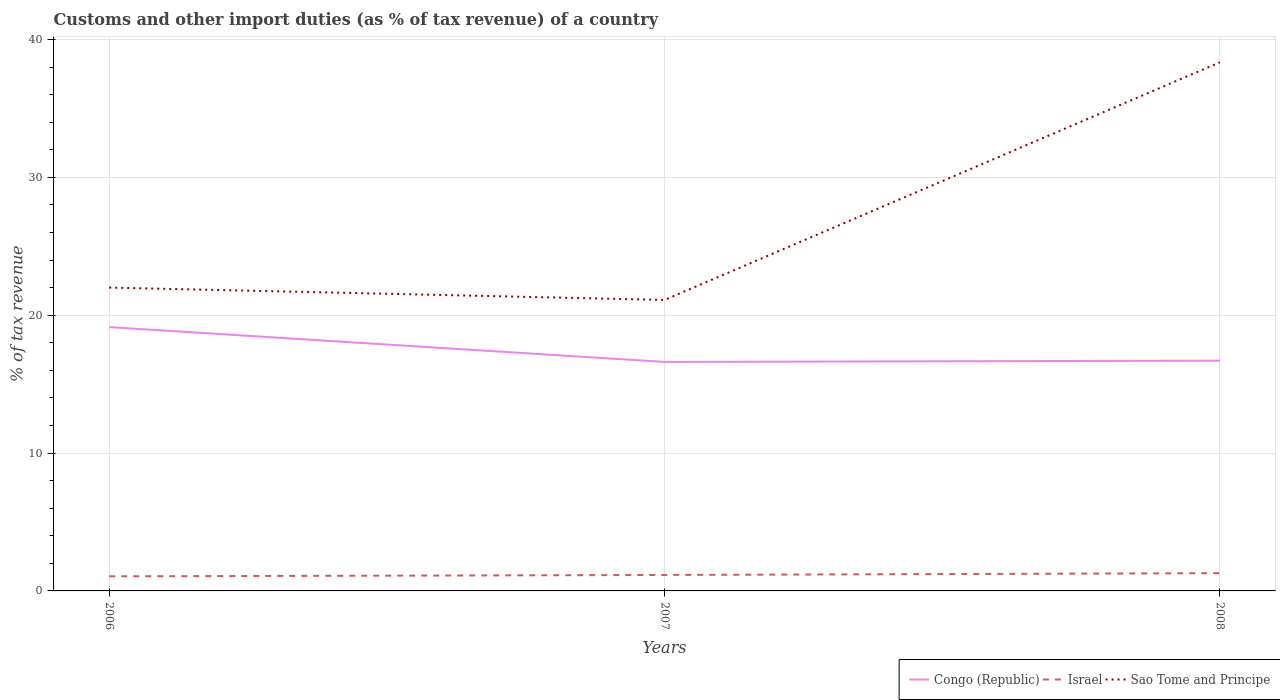Across all years, what is the maximum percentage of tax revenue from customs in Sao Tome and Principe?
Your answer should be compact. 21.11. In which year was the percentage of tax revenue from customs in Sao Tome and Principe maximum?
Make the answer very short. 2007. What is the total percentage of tax revenue from customs in Sao Tome and Principe in the graph?
Make the answer very short. -16.34. What is the difference between the highest and the second highest percentage of tax revenue from customs in Congo (Republic)?
Your answer should be compact. 2.53. How many years are there in the graph?
Your answer should be very brief. 3. What is the difference between two consecutive major ticks on the Y-axis?
Provide a short and direct response. 10. Are the values on the major ticks of Y-axis written in scientific E-notation?
Give a very brief answer. No. Does the graph contain any zero values?
Offer a very short reply. No. Where does the legend appear in the graph?
Ensure brevity in your answer.  Bottom right. How many legend labels are there?
Keep it short and to the point. 3. What is the title of the graph?
Provide a short and direct response. Customs and other import duties (as % of tax revenue) of a country. Does "Equatorial Guinea" appear as one of the legend labels in the graph?
Offer a terse response. No. What is the label or title of the X-axis?
Provide a short and direct response. Years. What is the label or title of the Y-axis?
Your answer should be compact. % of tax revenue. What is the % of tax revenue in Congo (Republic) in 2006?
Your answer should be compact. 19.14. What is the % of tax revenue of Israel in 2006?
Your answer should be compact. 1.06. What is the % of tax revenue of Sao Tome and Principe in 2006?
Offer a very short reply. 22. What is the % of tax revenue in Congo (Republic) in 2007?
Your answer should be very brief. 16.61. What is the % of tax revenue of Israel in 2007?
Your answer should be compact. 1.16. What is the % of tax revenue in Sao Tome and Principe in 2007?
Your answer should be compact. 21.11. What is the % of tax revenue of Congo (Republic) in 2008?
Provide a succinct answer. 16.7. What is the % of tax revenue in Israel in 2008?
Offer a very short reply. 1.29. What is the % of tax revenue of Sao Tome and Principe in 2008?
Your response must be concise. 38.35. Across all years, what is the maximum % of tax revenue in Congo (Republic)?
Provide a short and direct response. 19.14. Across all years, what is the maximum % of tax revenue in Israel?
Provide a succinct answer. 1.29. Across all years, what is the maximum % of tax revenue in Sao Tome and Principe?
Offer a very short reply. 38.35. Across all years, what is the minimum % of tax revenue in Congo (Republic)?
Provide a succinct answer. 16.61. Across all years, what is the minimum % of tax revenue in Israel?
Provide a succinct answer. 1.06. Across all years, what is the minimum % of tax revenue in Sao Tome and Principe?
Make the answer very short. 21.11. What is the total % of tax revenue of Congo (Republic) in the graph?
Provide a short and direct response. 52.45. What is the total % of tax revenue of Israel in the graph?
Your response must be concise. 3.5. What is the total % of tax revenue in Sao Tome and Principe in the graph?
Give a very brief answer. 81.46. What is the difference between the % of tax revenue of Congo (Republic) in 2006 and that in 2007?
Give a very brief answer. 2.53. What is the difference between the % of tax revenue of Israel in 2006 and that in 2007?
Offer a terse response. -0.1. What is the difference between the % of tax revenue of Sao Tome and Principe in 2006 and that in 2007?
Offer a very short reply. 0.9. What is the difference between the % of tax revenue in Congo (Republic) in 2006 and that in 2008?
Offer a very short reply. 2.43. What is the difference between the % of tax revenue of Israel in 2006 and that in 2008?
Your answer should be very brief. -0.23. What is the difference between the % of tax revenue of Sao Tome and Principe in 2006 and that in 2008?
Keep it short and to the point. -16.34. What is the difference between the % of tax revenue in Congo (Republic) in 2007 and that in 2008?
Keep it short and to the point. -0.09. What is the difference between the % of tax revenue in Israel in 2007 and that in 2008?
Provide a succinct answer. -0.13. What is the difference between the % of tax revenue of Sao Tome and Principe in 2007 and that in 2008?
Ensure brevity in your answer.  -17.24. What is the difference between the % of tax revenue of Congo (Republic) in 2006 and the % of tax revenue of Israel in 2007?
Your answer should be compact. 17.98. What is the difference between the % of tax revenue in Congo (Republic) in 2006 and the % of tax revenue in Sao Tome and Principe in 2007?
Your answer should be very brief. -1.97. What is the difference between the % of tax revenue of Israel in 2006 and the % of tax revenue of Sao Tome and Principe in 2007?
Your answer should be very brief. -20.05. What is the difference between the % of tax revenue of Congo (Republic) in 2006 and the % of tax revenue of Israel in 2008?
Make the answer very short. 17.85. What is the difference between the % of tax revenue of Congo (Republic) in 2006 and the % of tax revenue of Sao Tome and Principe in 2008?
Your response must be concise. -19.21. What is the difference between the % of tax revenue in Israel in 2006 and the % of tax revenue in Sao Tome and Principe in 2008?
Ensure brevity in your answer.  -37.29. What is the difference between the % of tax revenue of Congo (Republic) in 2007 and the % of tax revenue of Israel in 2008?
Make the answer very short. 15.32. What is the difference between the % of tax revenue of Congo (Republic) in 2007 and the % of tax revenue of Sao Tome and Principe in 2008?
Your answer should be compact. -21.74. What is the difference between the % of tax revenue in Israel in 2007 and the % of tax revenue in Sao Tome and Principe in 2008?
Provide a short and direct response. -37.19. What is the average % of tax revenue of Congo (Republic) per year?
Provide a short and direct response. 17.48. What is the average % of tax revenue of Israel per year?
Keep it short and to the point. 1.17. What is the average % of tax revenue of Sao Tome and Principe per year?
Offer a very short reply. 27.15. In the year 2006, what is the difference between the % of tax revenue of Congo (Republic) and % of tax revenue of Israel?
Offer a very short reply. 18.08. In the year 2006, what is the difference between the % of tax revenue in Congo (Republic) and % of tax revenue in Sao Tome and Principe?
Your answer should be compact. -2.87. In the year 2006, what is the difference between the % of tax revenue in Israel and % of tax revenue in Sao Tome and Principe?
Your answer should be compact. -20.95. In the year 2007, what is the difference between the % of tax revenue of Congo (Republic) and % of tax revenue of Israel?
Your response must be concise. 15.45. In the year 2007, what is the difference between the % of tax revenue of Congo (Republic) and % of tax revenue of Sao Tome and Principe?
Provide a short and direct response. -4.5. In the year 2007, what is the difference between the % of tax revenue in Israel and % of tax revenue in Sao Tome and Principe?
Ensure brevity in your answer.  -19.95. In the year 2008, what is the difference between the % of tax revenue in Congo (Republic) and % of tax revenue in Israel?
Your answer should be very brief. 15.42. In the year 2008, what is the difference between the % of tax revenue of Congo (Republic) and % of tax revenue of Sao Tome and Principe?
Provide a short and direct response. -21.64. In the year 2008, what is the difference between the % of tax revenue in Israel and % of tax revenue in Sao Tome and Principe?
Your answer should be compact. -37.06. What is the ratio of the % of tax revenue in Congo (Republic) in 2006 to that in 2007?
Your answer should be compact. 1.15. What is the ratio of the % of tax revenue in Israel in 2006 to that in 2007?
Give a very brief answer. 0.91. What is the ratio of the % of tax revenue in Sao Tome and Principe in 2006 to that in 2007?
Offer a terse response. 1.04. What is the ratio of the % of tax revenue of Congo (Republic) in 2006 to that in 2008?
Provide a short and direct response. 1.15. What is the ratio of the % of tax revenue in Israel in 2006 to that in 2008?
Your answer should be very brief. 0.82. What is the ratio of the % of tax revenue in Sao Tome and Principe in 2006 to that in 2008?
Offer a terse response. 0.57. What is the ratio of the % of tax revenue of Israel in 2007 to that in 2008?
Give a very brief answer. 0.9. What is the ratio of the % of tax revenue of Sao Tome and Principe in 2007 to that in 2008?
Ensure brevity in your answer.  0.55. What is the difference between the highest and the second highest % of tax revenue in Congo (Republic)?
Provide a succinct answer. 2.43. What is the difference between the highest and the second highest % of tax revenue in Israel?
Give a very brief answer. 0.13. What is the difference between the highest and the second highest % of tax revenue in Sao Tome and Principe?
Offer a terse response. 16.34. What is the difference between the highest and the lowest % of tax revenue in Congo (Republic)?
Your response must be concise. 2.53. What is the difference between the highest and the lowest % of tax revenue in Israel?
Keep it short and to the point. 0.23. What is the difference between the highest and the lowest % of tax revenue of Sao Tome and Principe?
Offer a terse response. 17.24. 